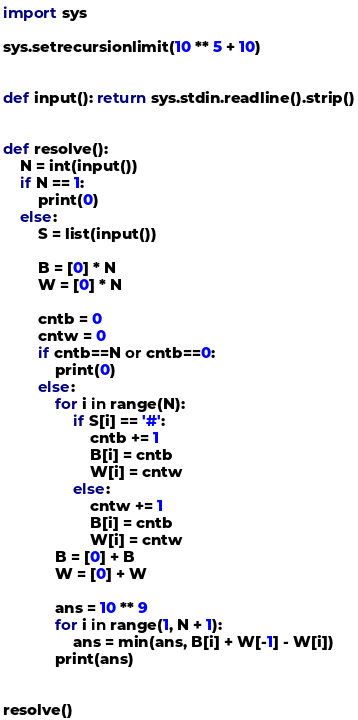<code> <loc_0><loc_0><loc_500><loc_500><_Python_>import sys

sys.setrecursionlimit(10 ** 5 + 10)


def input(): return sys.stdin.readline().strip()


def resolve():
    N = int(input())
    if N == 1:
        print(0)
    else:
        S = list(input())

        B = [0] * N
        W = [0] * N

        cntb = 0
        cntw = 0
        if cntb==N or cntb==0:
            print(0)
        else:
            for i in range(N):
                if S[i] == '#':
                    cntb += 1
                    B[i] = cntb
                    W[i] = cntw
                else:
                    cntw += 1
                    B[i] = cntb
                    W[i] = cntw
            B = [0] + B
            W = [0] + W

            ans = 10 ** 9
            for i in range(1, N + 1):
                ans = min(ans, B[i] + W[-1] - W[i])
            print(ans)


resolve()</code> 